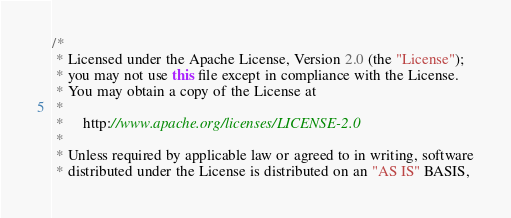Convert code to text. <code><loc_0><loc_0><loc_500><loc_500><_Java_>/*
 * Licensed under the Apache License, Version 2.0 (the "License");
 * you may not use this file except in compliance with the License.
 * You may obtain a copy of the License at
 *
 *     http://www.apache.org/licenses/LICENSE-2.0
 *
 * Unless required by applicable law or agreed to in writing, software
 * distributed under the License is distributed on an "AS IS" BASIS,</code> 